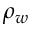<formula> <loc_0><loc_0><loc_500><loc_500>\rho _ { w }</formula> 